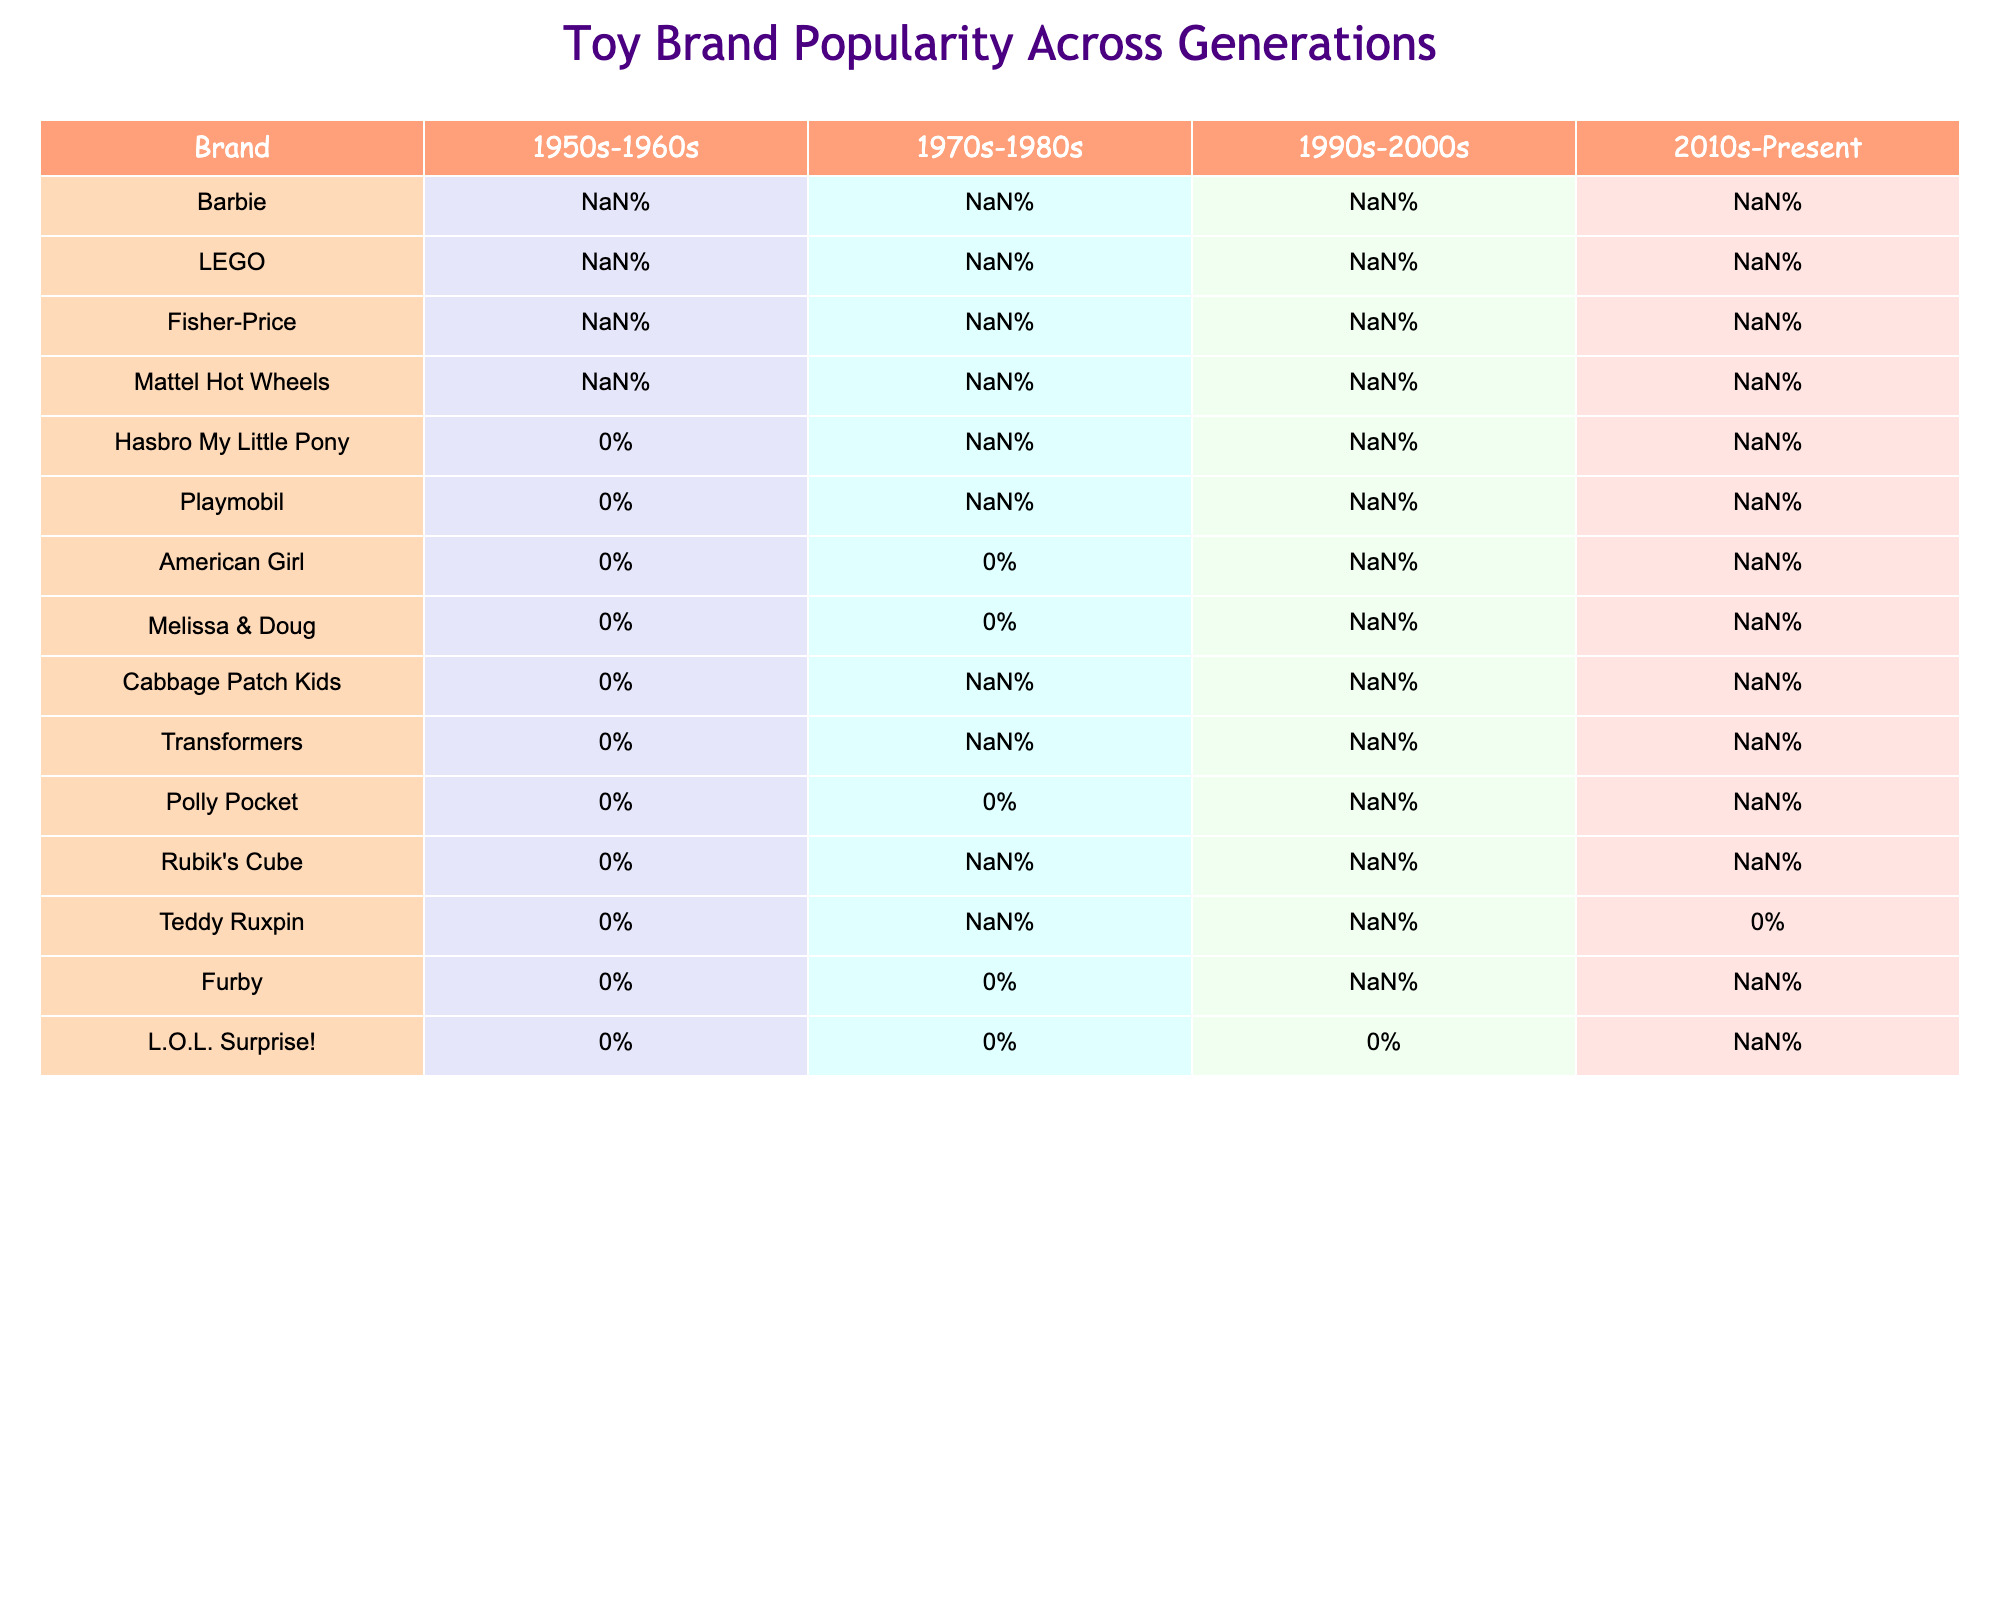What was the popularity percentage of LEGO in the 1990s-2000s? According to the table, LEGO's popularity percentage in the 1990s-2000s is 85%.
Answer: 85% Which brand saw a decrease in popularity from the 1970s-1980s to the 2010s-Present? By comparing the popularity percentages, Mattel Hot Wheels decreased from 70% in the 1970s-1980s to 60% in the 2010s-Present.
Answer: Mattel Hot Wheels Is there any brand that had a popularity percentage of 70% or more in all decades? Reviewing the data, no brand has a popularity percentage of 70% or more across all decades listed.
Answer: No What is the average popularity percentage of Fisher-Price across the decades it is presented? To find the average, we consider Fisher-Price's popularity percentages: 70%, 80%, 75%, and 70%. The average is (70 + 80 + 75 + 70) / 4 = 73.75%.
Answer: 73.75% Did L.O.L. Surprise! have any recorded popularity percentage before the 2010s? The table indicates that there are no recorded popularity percentages for L.O.L. Surprise! before the 2010s, as it shows "N/A" in earlier decades.
Answer: No What is the difference in popularity percentage for American Girl between the 1990s-2000s and the 2010s-Present? American Girl had a popularity percentage of 70% in the 1990s-2000s and 65% in the 2010s-Present. The difference is 70% - 65% = 5%.
Answer: 5% Which brand has the highest popularity in the 2010s-Present? From the table, LEGO has the highest popularity in the 2010s-Present with a percentage of 95%.
Answer: LEGO How did the popularity of Rubik's Cube change from the 1970s-1980s to the 2010s-Present? Rubik's Cube had a popularity of 85% in the 1970s-1980s and decreased to 60% in the 2010s-Present, indicating a drop of 25%.
Answer: Decreased by 25% What percentage did My Little Pony reach in the 2010s-Present? My Little Pony's popularity in the 2010s-Present is shown as 75%.
Answer: 75% 